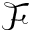Convert formula to latex. <formula><loc_0><loc_0><loc_500><loc_500>\mathcal { F }</formula> 